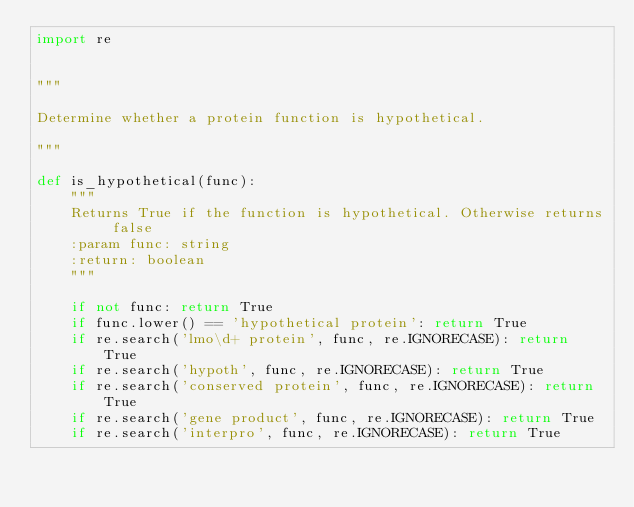<code> <loc_0><loc_0><loc_500><loc_500><_Python_>import re


"""

Determine whether a protein function is hypothetical.

"""

def is_hypothetical(func):
    """
    Returns True if the function is hypothetical. Otherwise returns false
    :param func: string
    :return: boolean
    """

    if not func: return True
    if func.lower() == 'hypothetical protein': return True
    if re.search('lmo\d+ protein', func, re.IGNORECASE): return True
    if re.search('hypoth', func, re.IGNORECASE): return True
    if re.search('conserved protein', func, re.IGNORECASE): return True
    if re.search('gene product', func, re.IGNORECASE): return True
    if re.search('interpro', func, re.IGNORECASE): return True</code> 